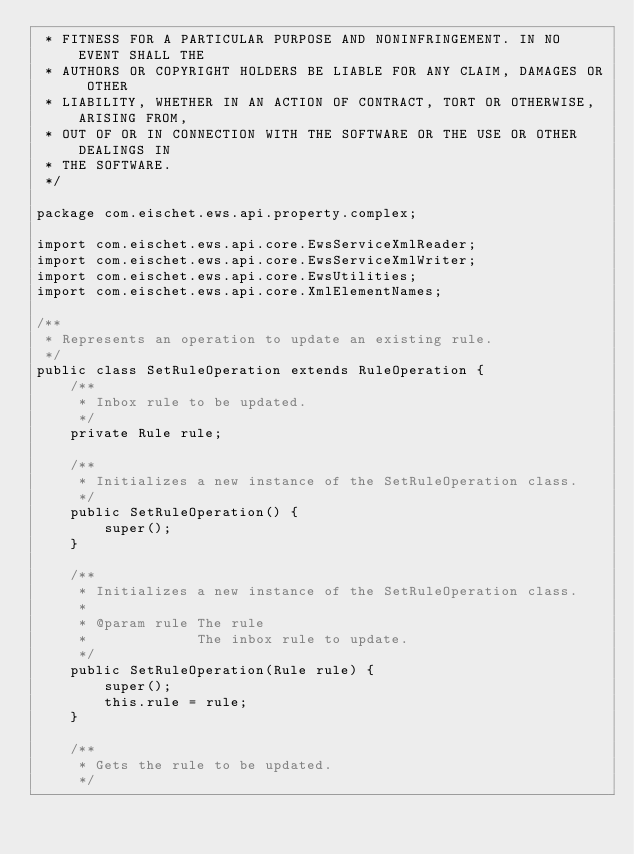Convert code to text. <code><loc_0><loc_0><loc_500><loc_500><_Java_> * FITNESS FOR A PARTICULAR PURPOSE AND NONINFRINGEMENT. IN NO EVENT SHALL THE
 * AUTHORS OR COPYRIGHT HOLDERS BE LIABLE FOR ANY CLAIM, DAMAGES OR OTHER
 * LIABILITY, WHETHER IN AN ACTION OF CONTRACT, TORT OR OTHERWISE, ARISING FROM,
 * OUT OF OR IN CONNECTION WITH THE SOFTWARE OR THE USE OR OTHER DEALINGS IN
 * THE SOFTWARE.
 */

package com.eischet.ews.api.property.complex;

import com.eischet.ews.api.core.EwsServiceXmlReader;
import com.eischet.ews.api.core.EwsServiceXmlWriter;
import com.eischet.ews.api.core.EwsUtilities;
import com.eischet.ews.api.core.XmlElementNames;

/**
 * Represents an operation to update an existing rule.
 */
public class SetRuleOperation extends RuleOperation {
    /**
     * Inbox rule to be updated.
     */
    private Rule rule;

    /**
     * Initializes a new instance of the SetRuleOperation class.
     */
    public SetRuleOperation() {
        super();
    }

    /**
     * Initializes a new instance of the SetRuleOperation class.
     *
     * @param rule The rule
     *             The inbox rule to update.
     */
    public SetRuleOperation(Rule rule) {
        super();
        this.rule = rule;
    }

    /**
     * Gets the rule to be updated.
     */</code> 